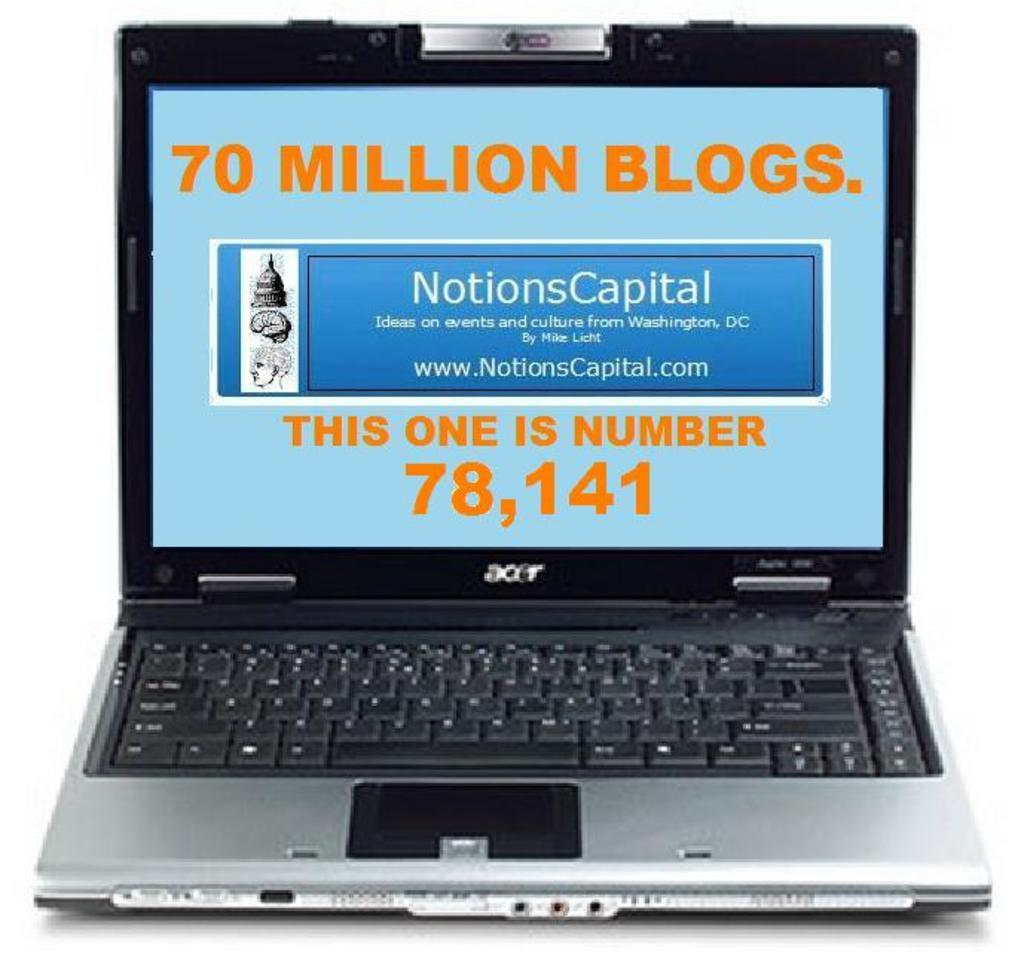<image>
Create a compact narrative representing the image presented. A laptop on a screen that shows 70 million blogs. 